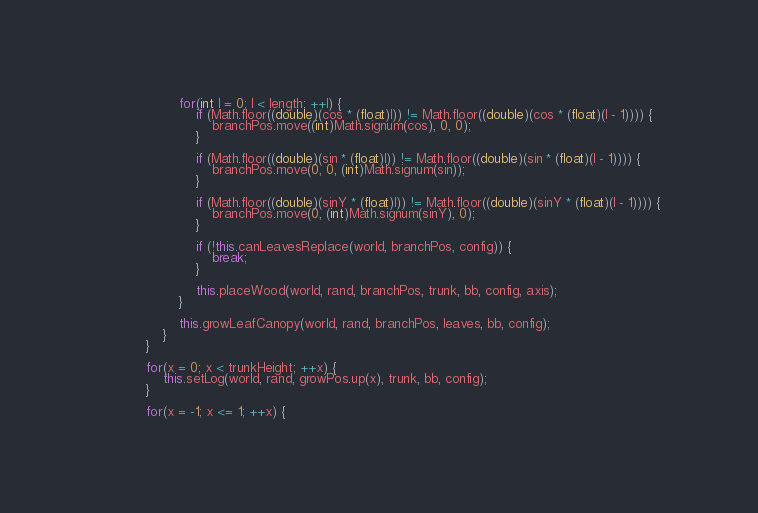Convert code to text. <code><loc_0><loc_0><loc_500><loc_500><_Java_>
                    for(int l = 0; l < length; ++l) {
                        if (Math.floor((double)(cos * (float)l)) != Math.floor((double)(cos * (float)(l - 1)))) {
                            branchPos.move((int)Math.signum(cos), 0, 0);
                        }

                        if (Math.floor((double)(sin * (float)l)) != Math.floor((double)(sin * (float)(l - 1)))) {
                            branchPos.move(0, 0, (int)Math.signum(sin));
                        }

                        if (Math.floor((double)(sinY * (float)l)) != Math.floor((double)(sinY * (float)(l - 1)))) {
                            branchPos.move(0, (int)Math.signum(sinY), 0);
                        }

                        if (!this.canLeavesReplace(world, branchPos, config)) {
                            break;
                        }

                        this.placeWood(world, rand, branchPos, trunk, bb, config, axis);
                    }

                    this.growLeafCanopy(world, rand, branchPos, leaves, bb, config);
                }
            }

            for(x = 0; x < trunkHeight; ++x) {
                this.setLog(world, rand, growPos.up(x), trunk, bb, config);
            }

            for(x = -1; x <= 1; ++x) {</code> 